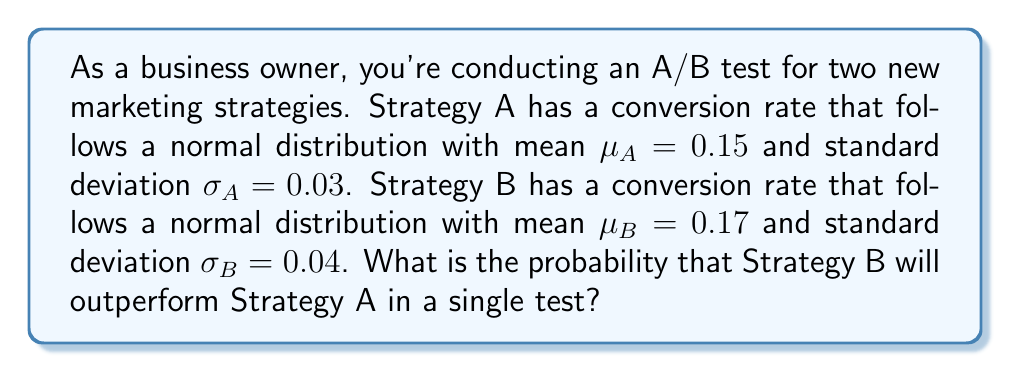Give your solution to this math problem. To solve this problem, we need to find the probability that Strategy B's conversion rate is higher than Strategy A's. Let's approach this step-by-step:

1) Let $X_A$ and $X_B$ represent the conversion rates for Strategy A and B respectively.

2) We're interested in $P(X_B > X_A)$, which is equivalent to $P(X_B - X_A > 0)$.

3) The difference between two normally distributed variables is also normally distributed. The mean and variance of this new distribution are:

   $\mu_{B-A} = \mu_B - \mu_A = 0.17 - 0.15 = 0.02$
   $\sigma^2_{B-A} = \sigma^2_B + \sigma^2_A = 0.04^2 + 0.03^2 = 0.0025$

4) Therefore, $X_B - X_A \sim N(0.02, \sqrt{0.0025})$

5) To find $P(X_B - X_A > 0)$, we need to standardize this distribution:

   $Z = \frac{(X_B - X_A) - \mu_{B-A}}{\sigma_{B-A}} = \frac{0 - 0.02}{\sqrt{0.0025}} = -0.4$

6) We want $P(Z > -0.4)$, which is equivalent to $1 - P(Z < -0.4)$

7) Using a standard normal distribution table or calculator:

   $P(Z < -0.4) \approx 0.3446$

8) Therefore, $P(Z > -0.4) = 1 - 0.3446 = 0.6554$

Thus, the probability that Strategy B will outperform Strategy A in a single test is approximately 0.6554 or 65.54%.
Answer: 0.6554 